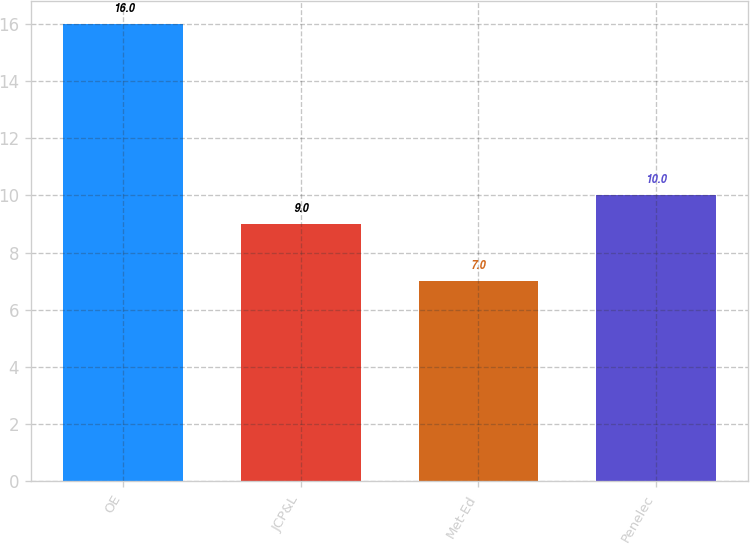Convert chart. <chart><loc_0><loc_0><loc_500><loc_500><bar_chart><fcel>OE<fcel>JCP&L<fcel>Met-Ed<fcel>Penelec<nl><fcel>16<fcel>9<fcel>7<fcel>10<nl></chart> 